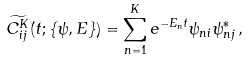Convert formula to latex. <formula><loc_0><loc_0><loc_500><loc_500>\widetilde { C ^ { K } _ { i j } } ( t ; \{ \psi , E \} ) = \sum _ { n = 1 } ^ { K } e ^ { - E _ { n } t } \psi _ { n i } \psi _ { n j } ^ { * } \, ,</formula> 